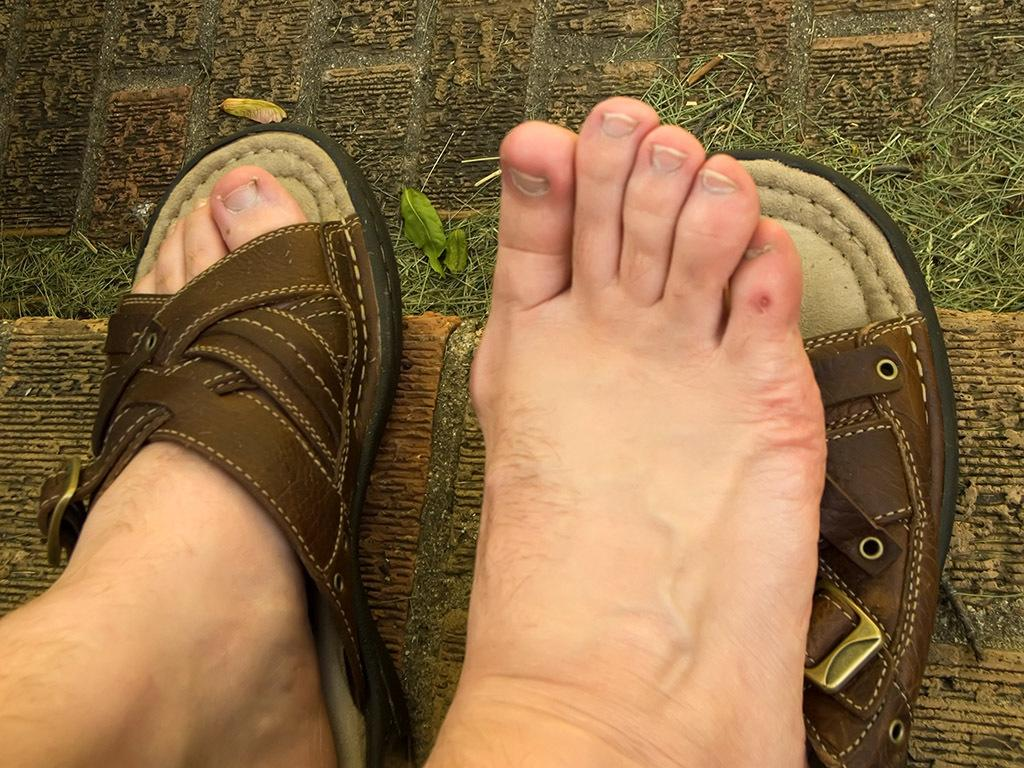What part of the person's body can be seen in the image? The person's legs are visible in the image. What type of footwear is the person wearing? The person's footwear is visible in the image. What can be seen in the background of the image? There is grass in the background of the image, and it is green in color. What type of sack is the person carrying in the image? There is no sack present in the image. How does the person walk on the grass in the image? The image does not show the person walking, so we cannot determine how they walk on the grass. 